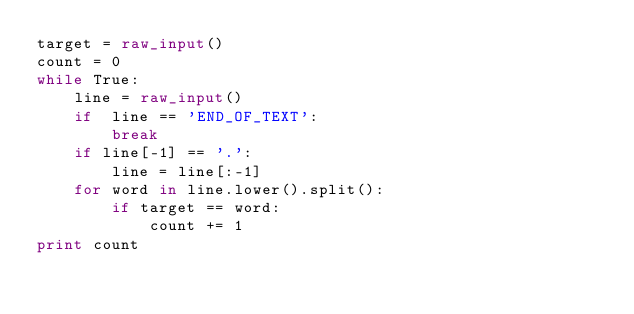Convert code to text. <code><loc_0><loc_0><loc_500><loc_500><_Python_>target = raw_input()
count = 0
while True:
    line = raw_input()
    if  line == 'END_OF_TEXT':
        break
    if line[-1] == '.':
        line = line[:-1]
    for word in line.lower().split():
        if target == word:
            count += 1
print count</code> 